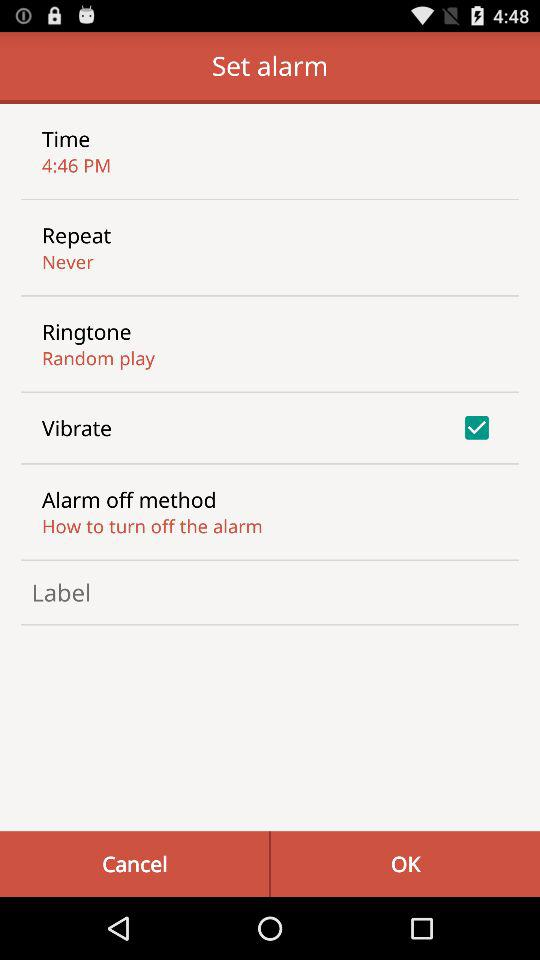What is the setting for the repeat? The setting for the repeat is "Never". 